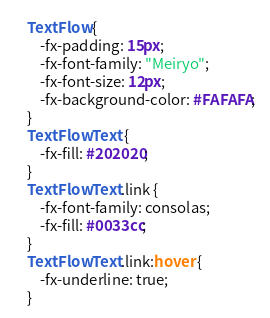<code> <loc_0><loc_0><loc_500><loc_500><_CSS_>TextFlow {
    -fx-padding: 15px;
	-fx-font-family: "Meiryo";
	-fx-font-size: 12px;
	-fx-background-color: #FAFAFA;
}
TextFlow Text {
    -fx-fill: #202020;
}
TextFlow Text.link {
	-fx-font-family: consolas;
    -fx-fill: #0033cc;
}
TextFlow Text.link:hover {
    -fx-underline: true;
}</code> 